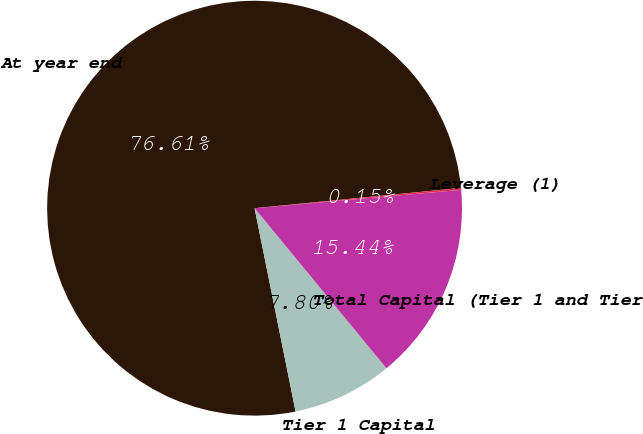<chart> <loc_0><loc_0><loc_500><loc_500><pie_chart><fcel>At year end<fcel>Tier 1 Capital<fcel>Total Capital (Tier 1 and Tier<fcel>Leverage (1)<nl><fcel>76.6%<fcel>7.8%<fcel>15.44%<fcel>0.15%<nl></chart> 